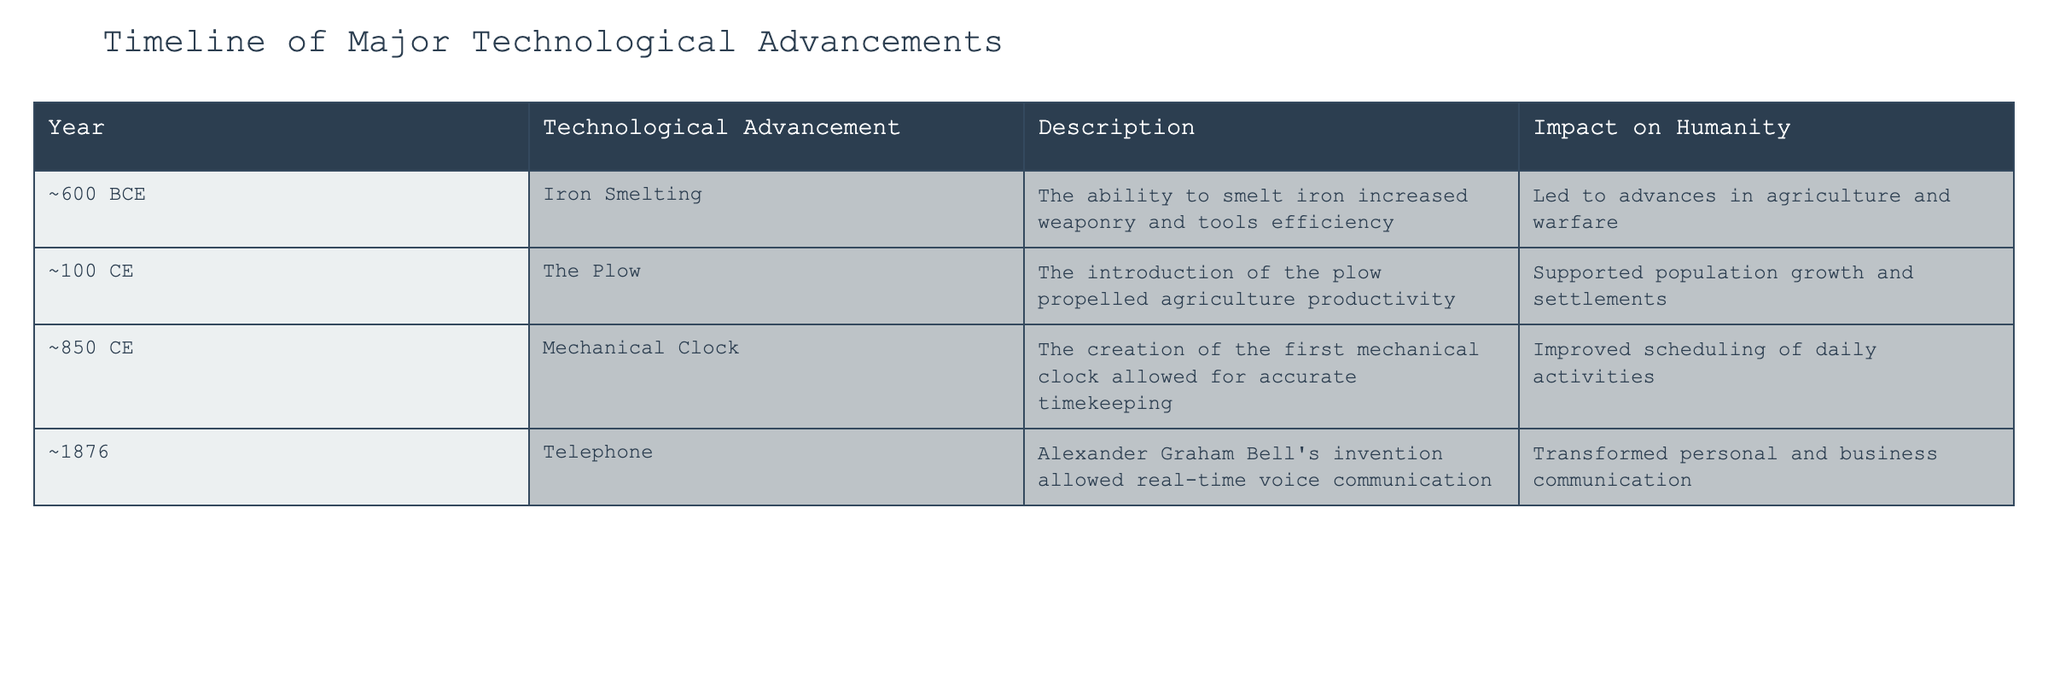What year was iron smelting introduced? The table lists iron smelting as being introduced around 600 BCE.
Answer: ~600 BCE What technological advancement followed the plow? The table indicates that the plow was introduced around 100 CE and the next advancement was the mechanical clock around 850 CE.
Answer: Mechanical Clock Which technological advancement had the greatest impact on communication? According to the table, the telephone invented in 1876 transformed personal and business communication significantly.
Answer: Telephone List all the technological advancements in chronological order. The advancements in chronological order are: Iron Smelting (~600 BCE), The Plow (~100 CE), Mechanical Clock (~850 CE), and Telephone (1876).
Answer: Iron Smelting, The Plow, Mechanical Clock, Telephone What was the primary impact of mechanical clocks on humanity? The table states that the mechanical clock allowed for accurate timekeeping, which improved scheduling of daily activities.
Answer: Improved scheduling of daily activities Is it true that the invention of the plow supported population growth? Yes, the description in the table explicitly states that the introduction of the plow supported population growth and settlements.
Answer: Yes How many advancements directly impacted warfare? The table shows that iron smelting had an impact on warfare, while the other advancements mainly focused on agriculture, timekeeping, and communication. This gives one advancement affecting warfare.
Answer: 1 What was the difference in years between the introduction of the plow and the telephone? The plow was introduced around 100 CE, and the telephone was invented in 1876. The difference in years is 1876 - 100 = 1776 years.
Answer: 1776 years Which advancement had a significant impact on agriculture, and what was its specific effect? The plow is listed as having a significant impact on agriculture by propelling productivity, which supported population growth and settlements.
Answer: The Plow, supported population growth What were the overall implications of technological advancements mentioned in the table on the evolution of human society? Each technological advancement contributed significantly, with the plow facilitating more settled communities, iron smelting enhancing warfare and tool-making, mechanical clocks improving daily organization, and the telephone revolutionizing communication, leading to interconnectedness in society.
Answer: They facilitated settled communities, improved organization, and enhanced communication 